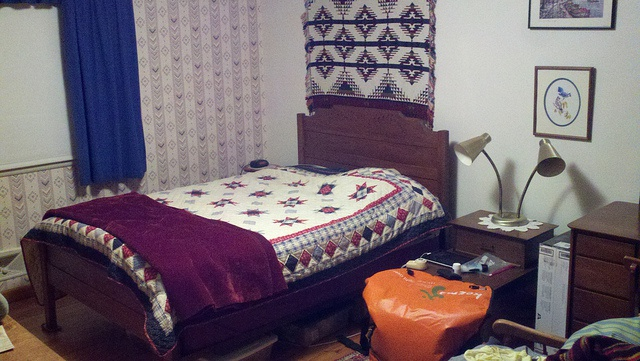Describe the objects in this image and their specific colors. I can see bed in navy, black, purple, and beige tones, suitcase in navy, red, salmon, black, and maroon tones, and chair in navy, black, gray, olive, and darkgray tones in this image. 